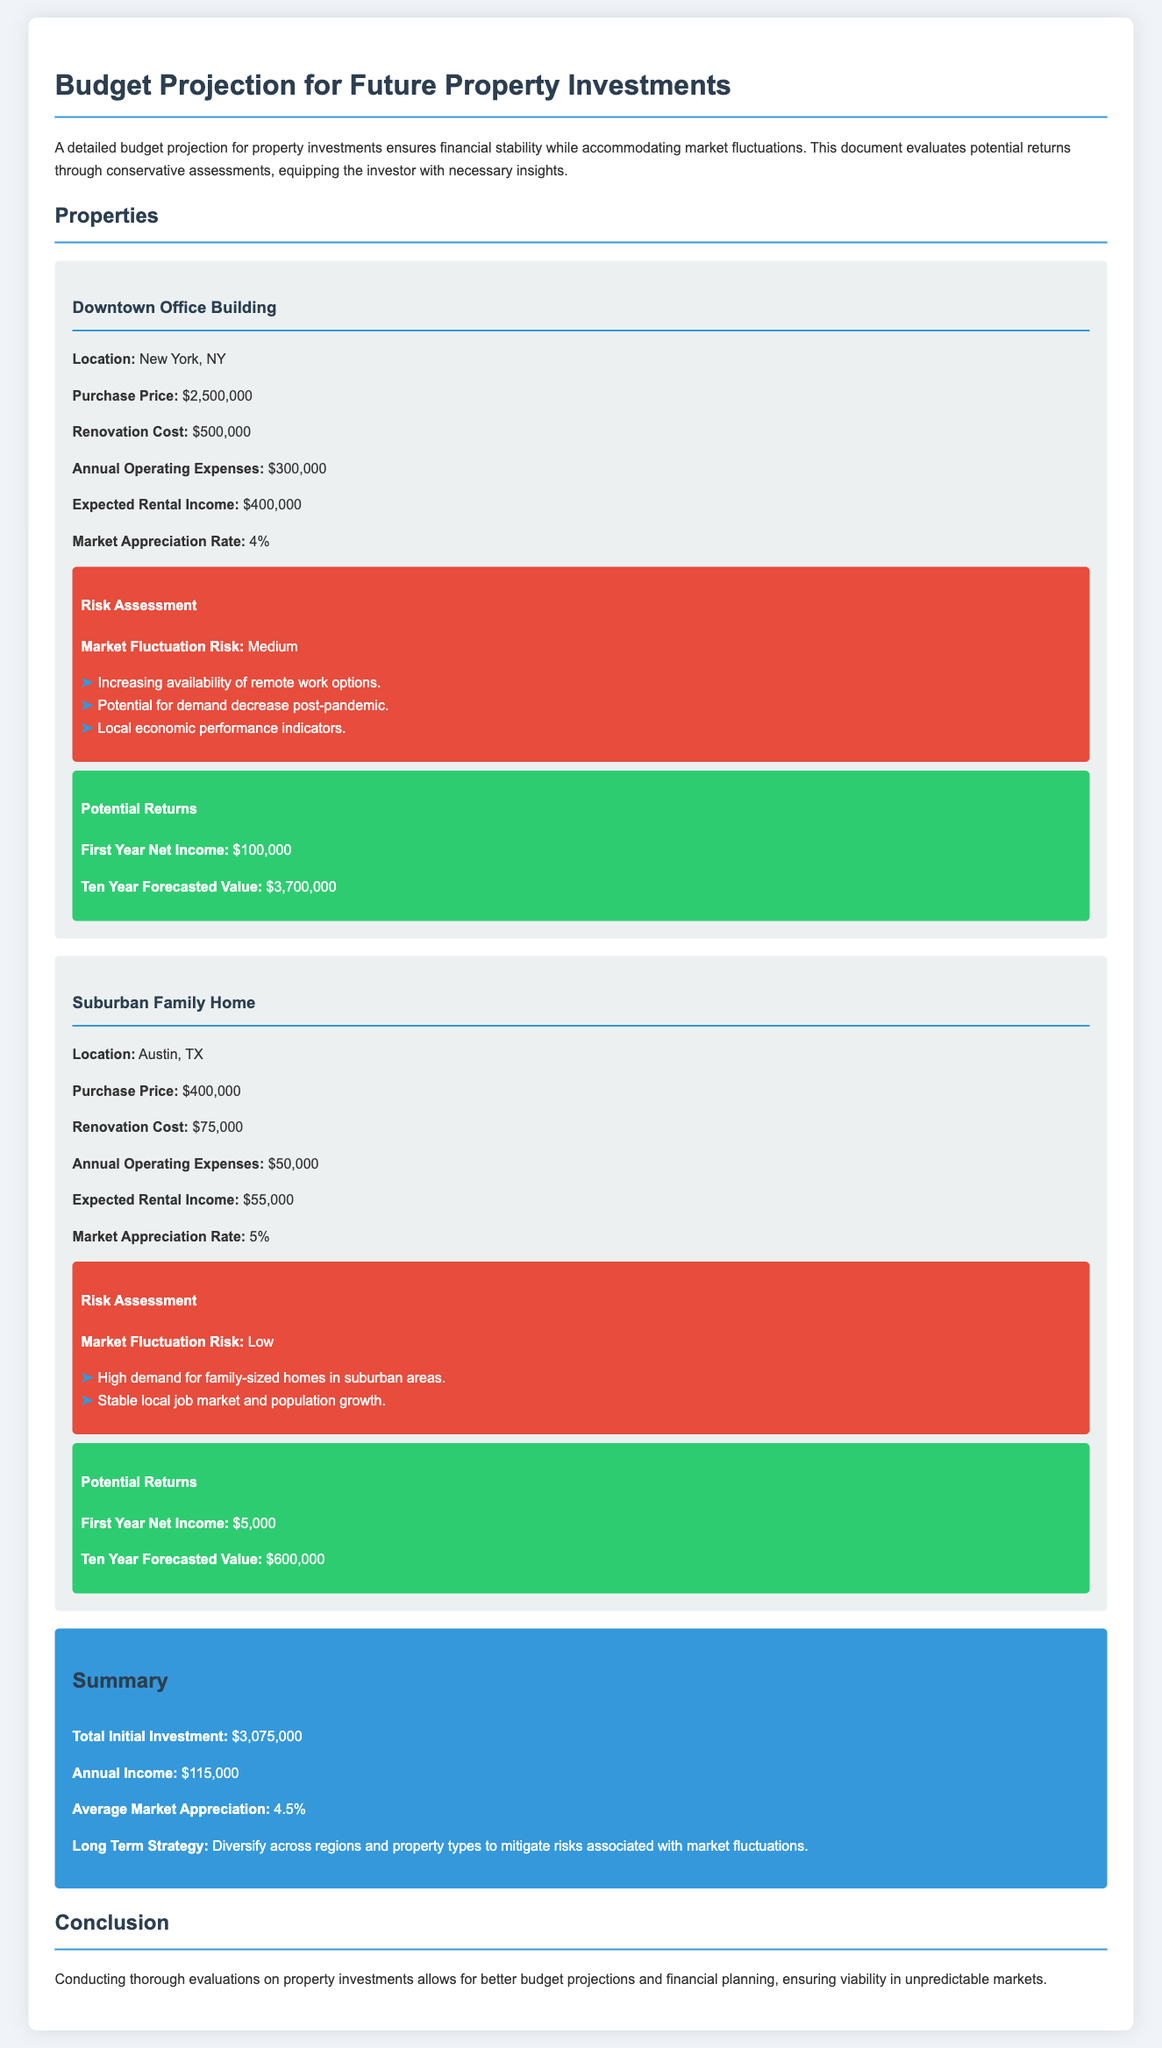what is the purchase price of the Downtown Office Building? The purchase price is specifically mentioned in the document as $2,500,000 for the Downtown Office Building.
Answer: $2,500,000 what is the expected rental income for the Suburban Family Home? The expected rental income is clearly listed in the document as $55,000 for the Suburban Family Home.
Answer: $55,000 what is the market appreciation rate for the Downtown Office Building? The document states that the market appreciation rate is 4% for the Downtown Office Building.
Answer: 4% what is the total initial investment? The total initial investment is calculated from the sums of the purchase price and renovation costs mentioned, which totals $3,075,000.
Answer: $3,075,000 how does the risk assessment classify the Downtown Office Building's market fluctuation risk? The document provides the risk assessment classification as Medium for the Downtown Office Building's market fluctuation risk.
Answer: Medium what is the first year net income for the Downtown Office Building? The document provides the first year net income as $100,000 for the Downtown Office Building.
Answer: $100,000 what is the long-term strategy suggested in the summary? The summary suggests a long-term strategy to diversify across regions and property types to mitigate risks.
Answer: Diversify across regions and property types what is the annual operating expense for the Suburban Family Home? The document lists the annual operating expense as $50,000 for the Suburban Family Home.
Answer: $50,000 what is the ten-year forecasted value of the Suburban Family Home? The ten-year forecasted value is explicitly mentioned in the document as $600,000 for the Suburban Family Home.
Answer: $600,000 